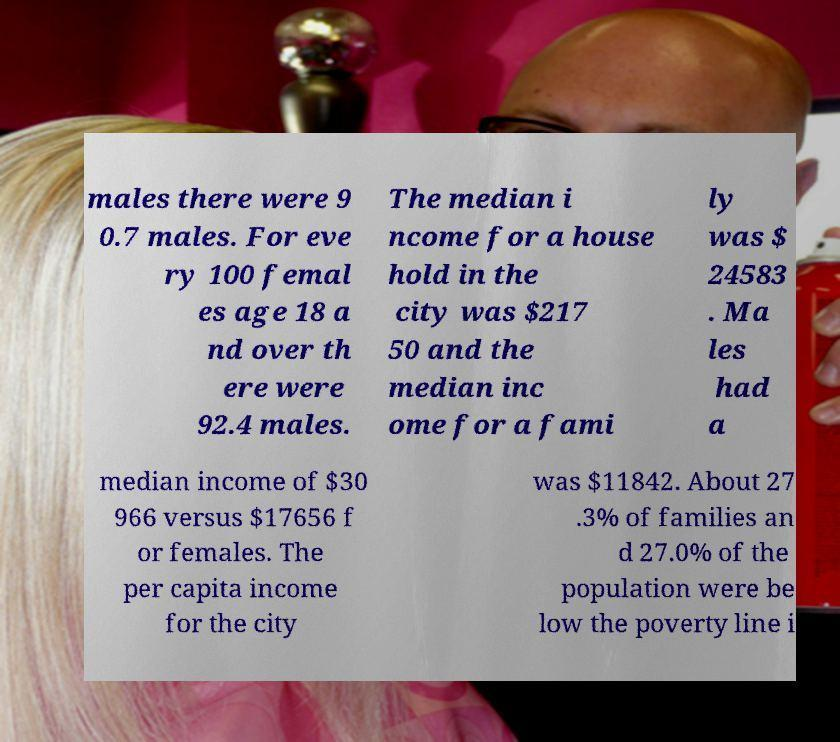Can you read and provide the text displayed in the image?This photo seems to have some interesting text. Can you extract and type it out for me? males there were 9 0.7 males. For eve ry 100 femal es age 18 a nd over th ere were 92.4 males. The median i ncome for a house hold in the city was $217 50 and the median inc ome for a fami ly was $ 24583 . Ma les had a median income of $30 966 versus $17656 f or females. The per capita income for the city was $11842. About 27 .3% of families an d 27.0% of the population were be low the poverty line i 